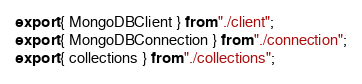<code> <loc_0><loc_0><loc_500><loc_500><_TypeScript_>export { MongoDBClient } from "./client";
export { MongoDBConnection } from "./connection";
export { collections } from "./collections";
</code> 